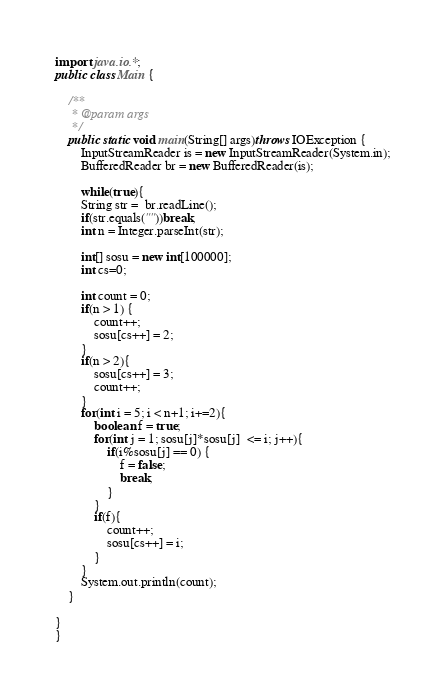Convert code to text. <code><loc_0><loc_0><loc_500><loc_500><_Java_>import java.io.*;
public class Main {

	/**
	 * @param args
	 */
	public static void main(String[] args)throws IOException {
		InputStreamReader is = new InputStreamReader(System.in);
		BufferedReader br = new BufferedReader(is);		
		
		while(true){
		String str =  br.readLine();
		if(str.equals(""))break;
		int n = Integer.parseInt(str);
		
		int[] sosu = new int[100000];
		int cs=0;
		
		int count = 0;
		if(n > 1) {
			count++;
			sosu[cs++] = 2;
		}
		if(n > 2){
			sosu[cs++] = 3;
			count++;
		}
		for(int i = 5; i < n+1; i+=2){
			boolean f = true;
			for(int j = 1; sosu[j]*sosu[j]  <= i; j++){
				if(i%sosu[j] == 0) {
					f = false;
					break;
				}
			}
			if(f){
				count++;
				sosu[cs++] = i;
			}
		}
		System.out.println(count);
	}

}
}</code> 